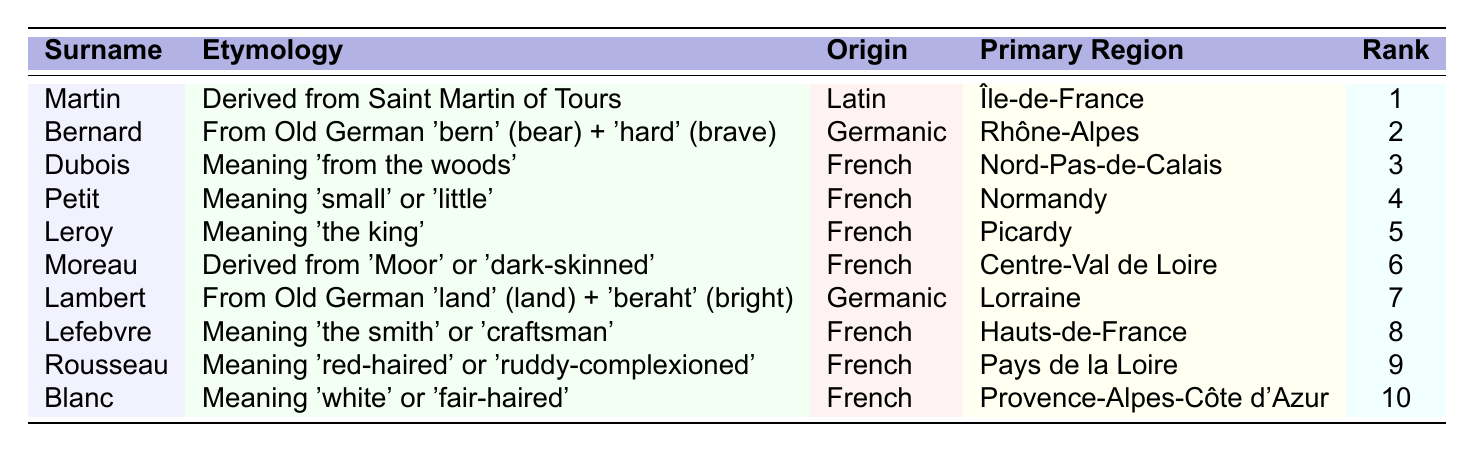What is the etymology of the surname "Rousseau"? The etymology of "Rousseau" is provided in the table as "Meaning 'red-haired' or 'ruddy-complexioned'."
Answer: Meaning 'red-haired' or 'ruddy-complexioned' Which surname has the highest frequency rank? The surname with the highest frequency rank, as indicated in the table, is "Martin," with a rank of 1.
Answer: Martin Is "Blanc" derived from a Latin origin? "Blanc" is listed as having a French origin, not Latin, so the statement is false.
Answer: No What is the primary region associated with the surname "Lefebvre"? The primary region for "Lefebvre" is noted in the table as "Hauts-de-France."
Answer: Hauts-de-France How many surnames in the table have their origin in Germanic? The table lists two surnames with Germanic origin: "Bernard" and "Lambert." Thus, the count is 2.
Answer: 2 Which surname means 'the king' and what is its frequency rank? "Leroy" is the surname meaning 'the king,' and its frequency rank is 5, as stated in the table.
Answer: Leroy, 5 If you combine the frequency ranks of "Martin" and "Dubois," what is the total? The frequency rank of "Martin" is 1 and "Dubois" is 3. Adding these yields 1 + 3 = 4.
Answer: 4 Which surname has a meaning associated with the color 'white'? The surname "Blanc" means 'white' or 'fair-haired' according to the table.
Answer: Blanc Is there a surname with origins from the Latin language? Yes, "Martin" is derived from Latin, specifically from Saint Martin of Tours.
Answer: Yes What is the average frequency rank of the surnames listed in the table? The sum of all frequency ranks from 1 to 10 results in 55 (1+2+3+4+5+6+7+8+9+10=55). The number of surnames is 10. Thus, the average is 55/10 = 5.5.
Answer: 5.5 Which surname has both a French origin and a meaning related to size? "Petit," which means 'small' or 'little,' has a French origin as noted in the table.
Answer: Petit 